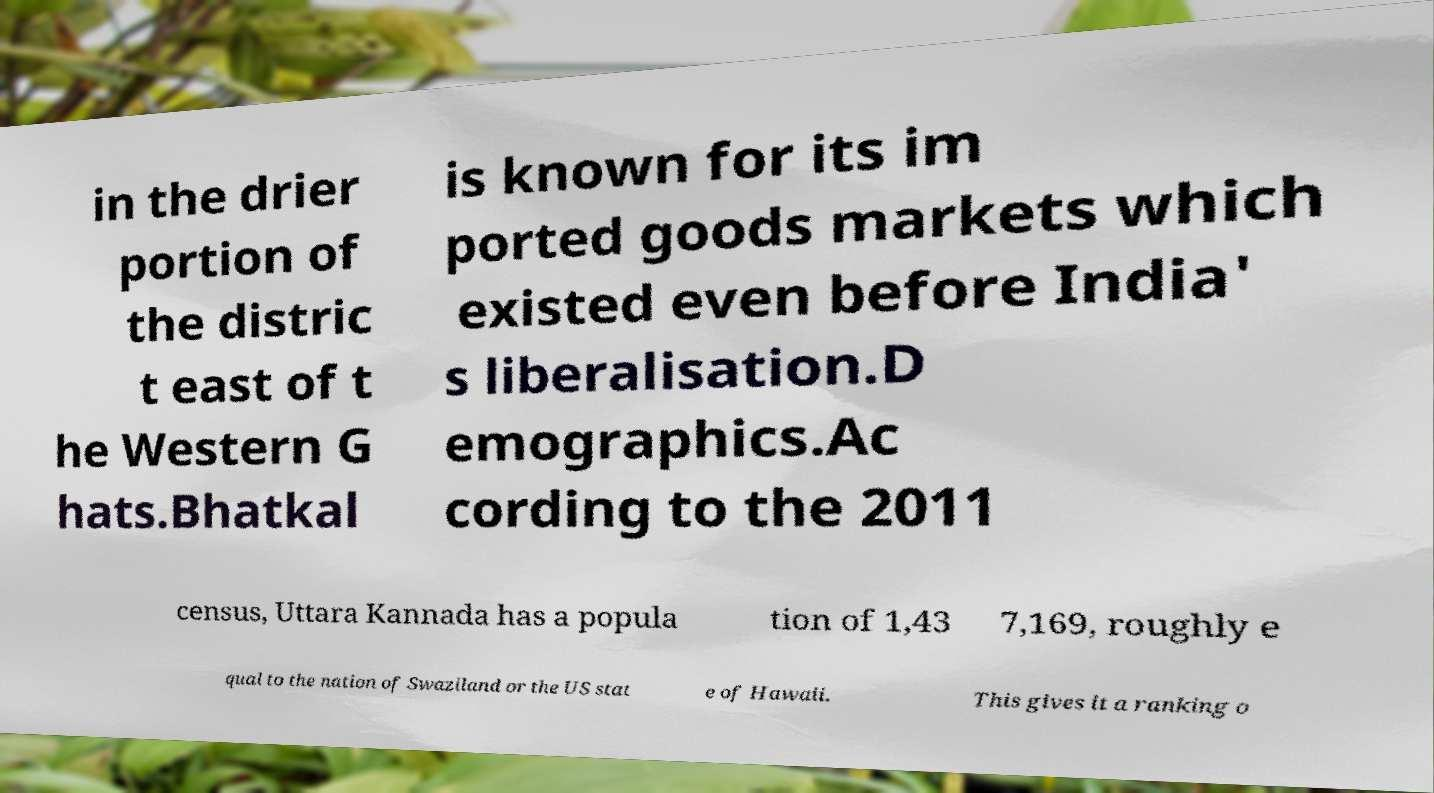Please identify and transcribe the text found in this image. in the drier portion of the distric t east of t he Western G hats.Bhatkal is known for its im ported goods markets which existed even before India' s liberalisation.D emographics.Ac cording to the 2011 census, Uttara Kannada has a popula tion of 1,43 7,169, roughly e qual to the nation of Swaziland or the US stat e of Hawaii. This gives it a ranking o 